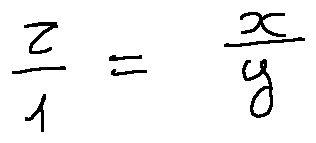<formula> <loc_0><loc_0><loc_500><loc_500>\frac { z } { 1 } = \frac { x } { y }</formula> 